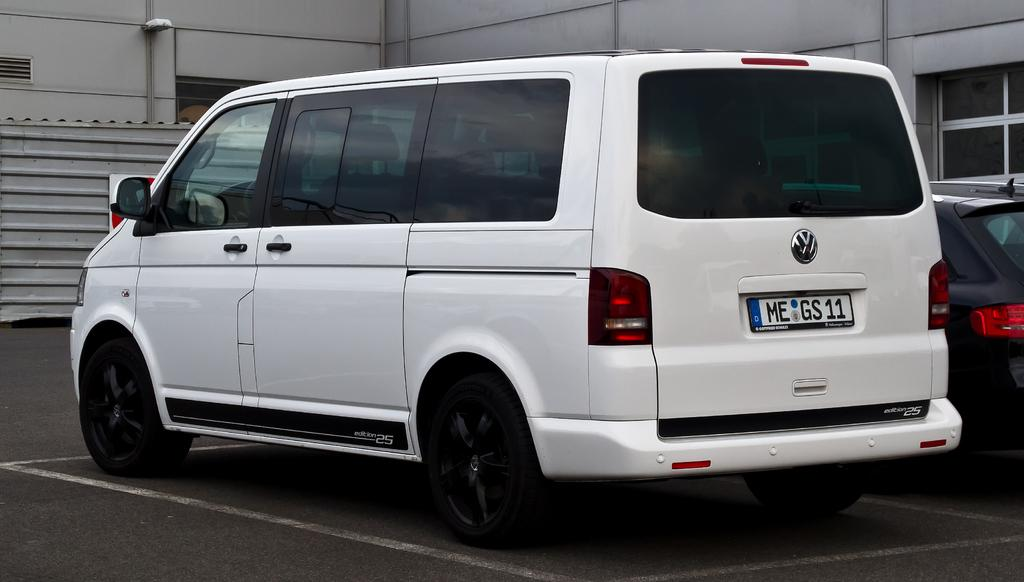<image>
Write a terse but informative summary of the picture. A white Volkswagen van has a license plate that says ME GS11 on it. 